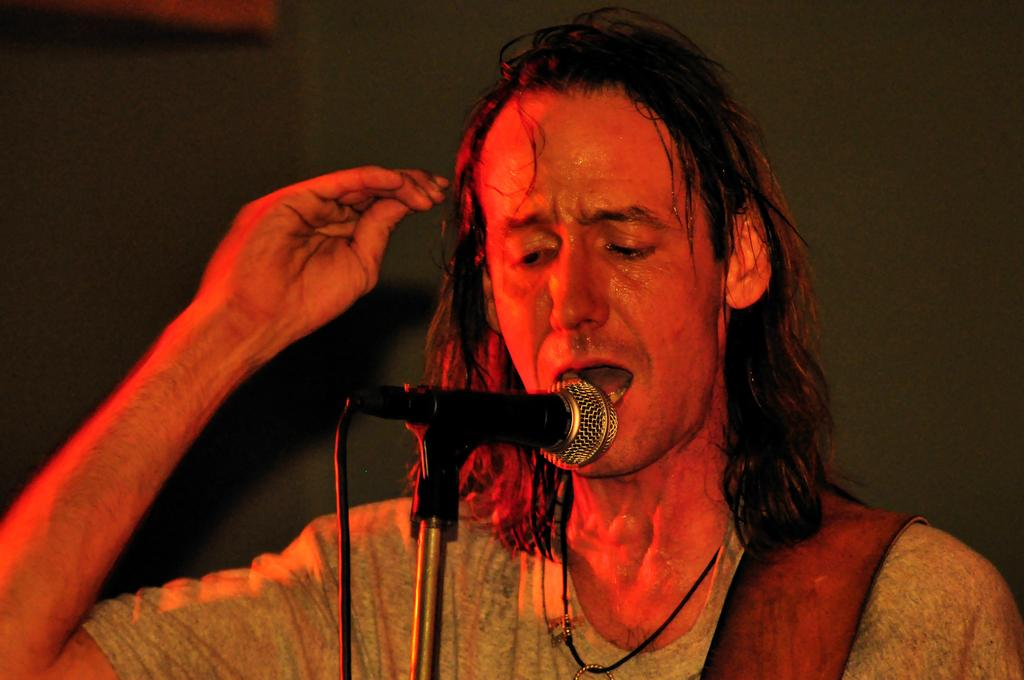Who or what is the main subject in the image? There is a person in the image. What is the person wearing? The person is wearing a dress. What is the person doing in the image? The person is standing in front of a microphone. What is the color of the background in the image? The background of the image is black. What type of calculator can be seen on the table next to the person in the image? There is no calculator present in the image. How many books are visible on the shelf behind the person in the image? There are no books visible in the image; the background is black. 